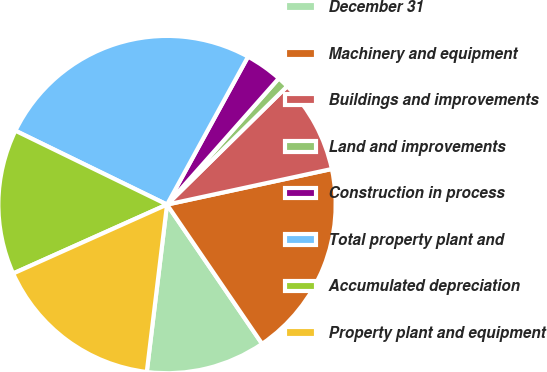<chart> <loc_0><loc_0><loc_500><loc_500><pie_chart><fcel>December 31<fcel>Machinery and equipment<fcel>Buildings and improvements<fcel>Land and improvements<fcel>Construction in process<fcel>Total property plant and<fcel>Accumulated depreciation<fcel>Property plant and equipment<nl><fcel>11.45%<fcel>18.85%<fcel>8.99%<fcel>1.09%<fcel>3.56%<fcel>25.76%<fcel>13.92%<fcel>16.38%<nl></chart> 